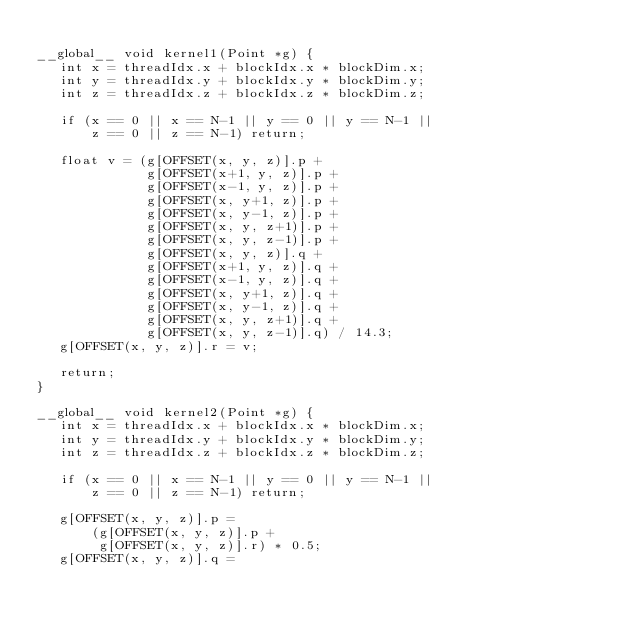Convert code to text. <code><loc_0><loc_0><loc_500><loc_500><_Cuda_>
__global__ void kernel1(Point *g) {
   int x = threadIdx.x + blockIdx.x * blockDim.x;
   int y = threadIdx.y + blockIdx.y * blockDim.y;
   int z = threadIdx.z + blockIdx.z * blockDim.z;

   if (x == 0 || x == N-1 || y == 0 || y == N-1 ||
       z == 0 || z == N-1) return;

   float v = (g[OFFSET(x, y, z)].p +
              g[OFFSET(x+1, y, z)].p +
              g[OFFSET(x-1, y, z)].p +
              g[OFFSET(x, y+1, z)].p +
              g[OFFSET(x, y-1, z)].p +
              g[OFFSET(x, y, z+1)].p +
              g[OFFSET(x, y, z-1)].p +
              g[OFFSET(x, y, z)].q +
              g[OFFSET(x+1, y, z)].q +
              g[OFFSET(x-1, y, z)].q +
              g[OFFSET(x, y+1, z)].q +
              g[OFFSET(x, y-1, z)].q +
              g[OFFSET(x, y, z+1)].q +
              g[OFFSET(x, y, z-1)].q) / 14.3;
   g[OFFSET(x, y, z)].r = v;

   return;
}

__global__ void kernel2(Point *g) {
   int x = threadIdx.x + blockIdx.x * blockDim.x;
   int y = threadIdx.y + blockIdx.y * blockDim.y;
   int z = threadIdx.z + blockIdx.z * blockDim.z;

   if (x == 0 || x == N-1 || y == 0 || y == N-1 ||
       z == 0 || z == N-1) return;

   g[OFFSET(x, y, z)].p =
       (g[OFFSET(x, y, z)].p +
        g[OFFSET(x, y, z)].r) * 0.5;
   g[OFFSET(x, y, z)].q =</code> 